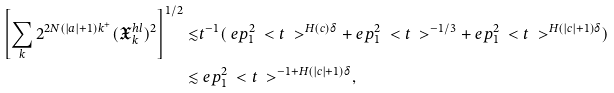Convert formula to latex. <formula><loc_0><loc_0><loc_500><loc_500>\left [ \sum _ { k } 2 ^ { 2 N ( | a | + 1 ) k ^ { + } } ( \mathfrak { X } ^ { h l } _ { k } ) ^ { 2 } \right ] ^ { 1 / 2 } \lesssim & t ^ { - 1 } ( \ e p _ { 1 } ^ { 2 } \ < t \ > ^ { H ( c ) \delta } + \ e p _ { 1 } ^ { 2 } \ < t \ > ^ { - 1 / 3 } + \ e p _ { 1 } ^ { 2 } \ < t \ > ^ { H ( | c | + 1 ) \delta } ) \\ \lesssim & \ e p _ { 1 } ^ { 2 } \ < t \ > ^ { - 1 + H ( | c | + 1 ) \delta } ,</formula> 